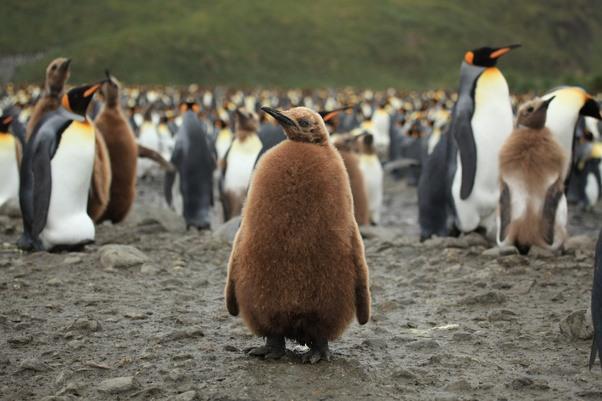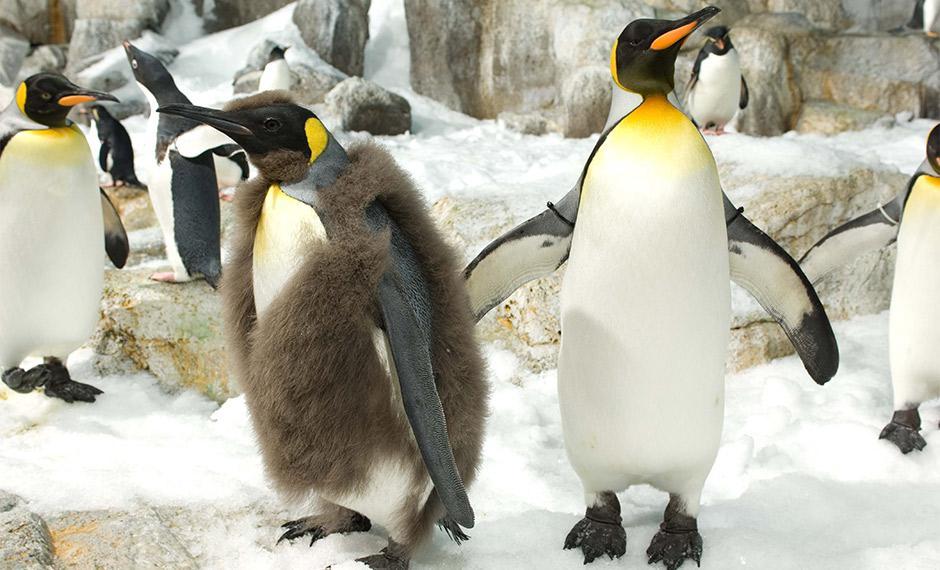The first image is the image on the left, the second image is the image on the right. Analyze the images presented: Is the assertion "There is at least one brown furry penguin." valid? Answer yes or no. Yes. The first image is the image on the left, the second image is the image on the right. Considering the images on both sides, is "An image includes multiple penguins with fuzzy brown feathers, along with at least one black and white penguin." valid? Answer yes or no. Yes. 